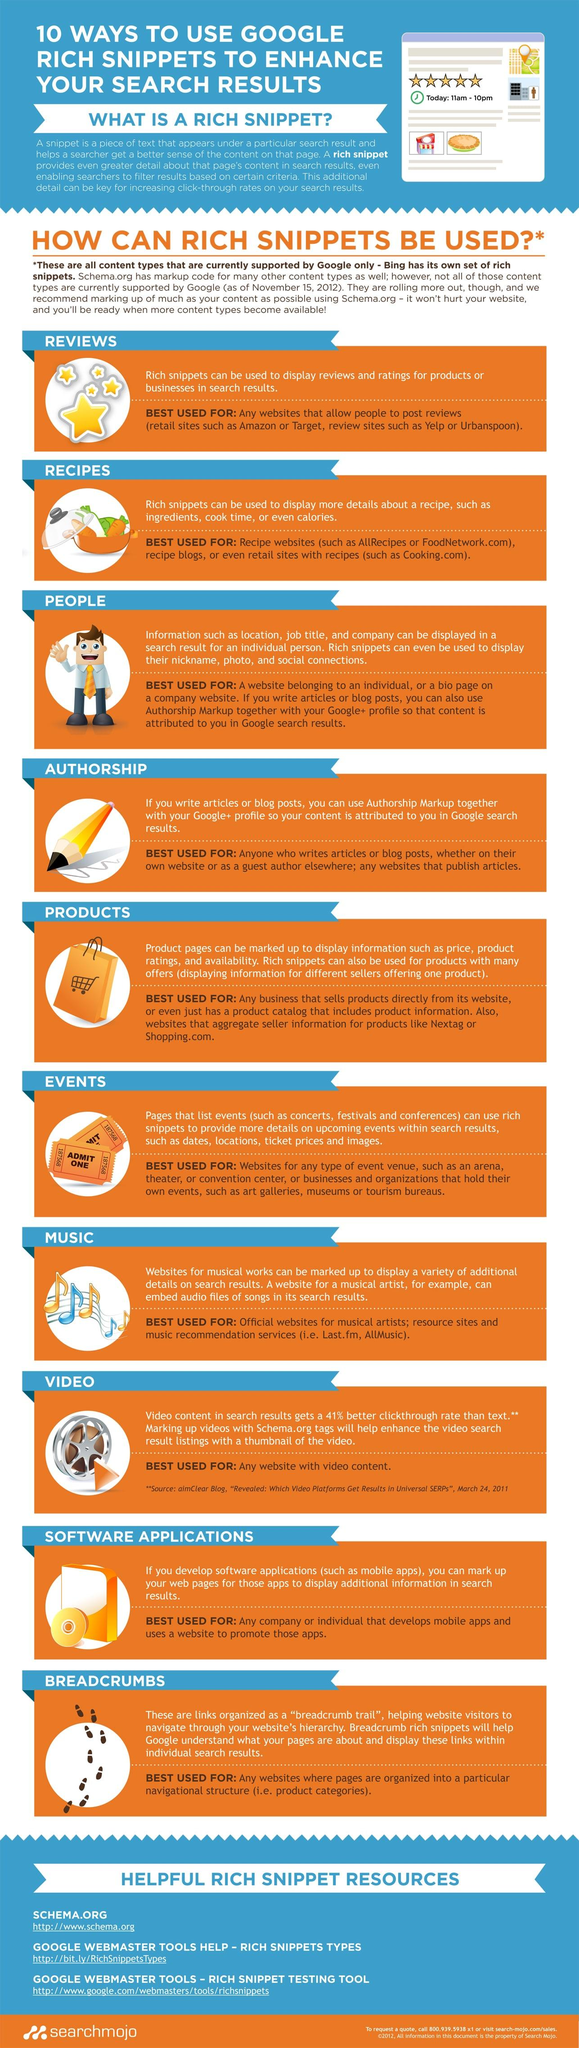Outline some significant characteristics in this image. The website link provided for the first helpful rich snippet resource is <http://www.schema.org>. Rich snippets are utilized given second to last in the provided list for software applications. This infographic provides three helpful resources for rich snippets. The use of rich snippets, as stated in the given infographic, is the second one, which is for recipes. There are 10 uses of rich snippets in this infographic. 